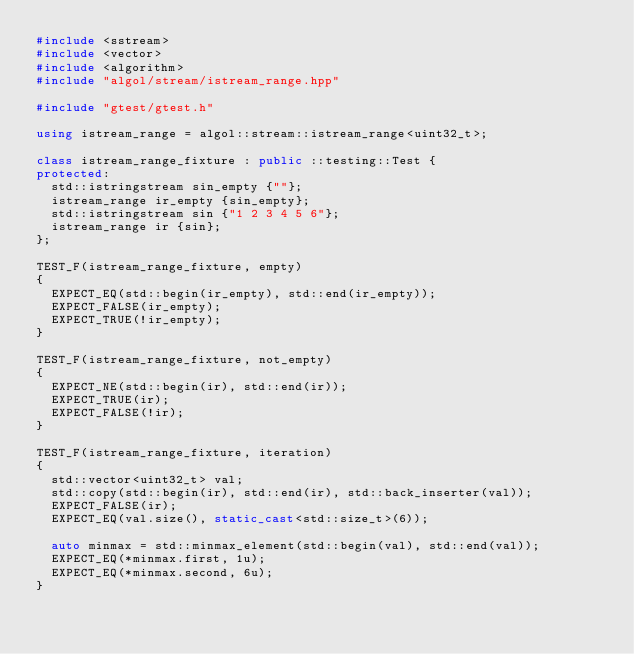<code> <loc_0><loc_0><loc_500><loc_500><_C++_>#include <sstream>
#include <vector>
#include <algorithm>
#include "algol/stream/istream_range.hpp"

#include "gtest/gtest.h"

using istream_range = algol::stream::istream_range<uint32_t>;

class istream_range_fixture : public ::testing::Test {
protected:
  std::istringstream sin_empty {""};
  istream_range ir_empty {sin_empty};
  std::istringstream sin {"1 2 3 4 5 6"};
  istream_range ir {sin};
};

TEST_F(istream_range_fixture, empty)
{
  EXPECT_EQ(std::begin(ir_empty), std::end(ir_empty));
  EXPECT_FALSE(ir_empty);
  EXPECT_TRUE(!ir_empty);
}

TEST_F(istream_range_fixture, not_empty)
{
  EXPECT_NE(std::begin(ir), std::end(ir));
  EXPECT_TRUE(ir);
  EXPECT_FALSE(!ir);
}

TEST_F(istream_range_fixture, iteration)
{
  std::vector<uint32_t> val;
  std::copy(std::begin(ir), std::end(ir), std::back_inserter(val));
  EXPECT_FALSE(ir);
  EXPECT_EQ(val.size(), static_cast<std::size_t>(6));

  auto minmax = std::minmax_element(std::begin(val), std::end(val));
  EXPECT_EQ(*minmax.first, 1u);
  EXPECT_EQ(*minmax.second, 6u);
}</code> 